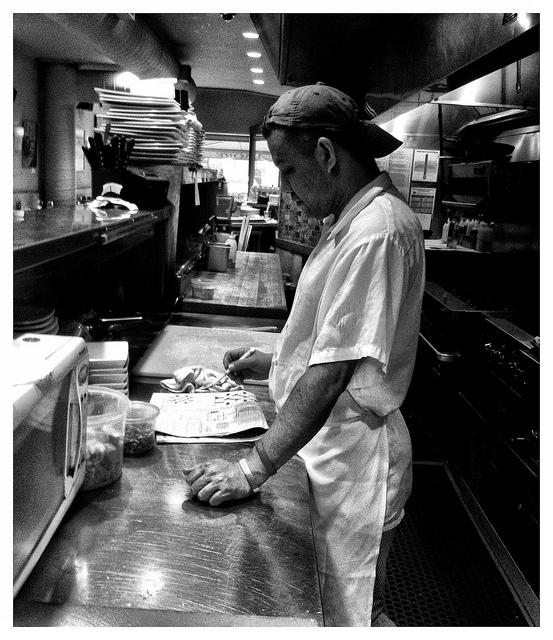What is this person's likely job title? chef 